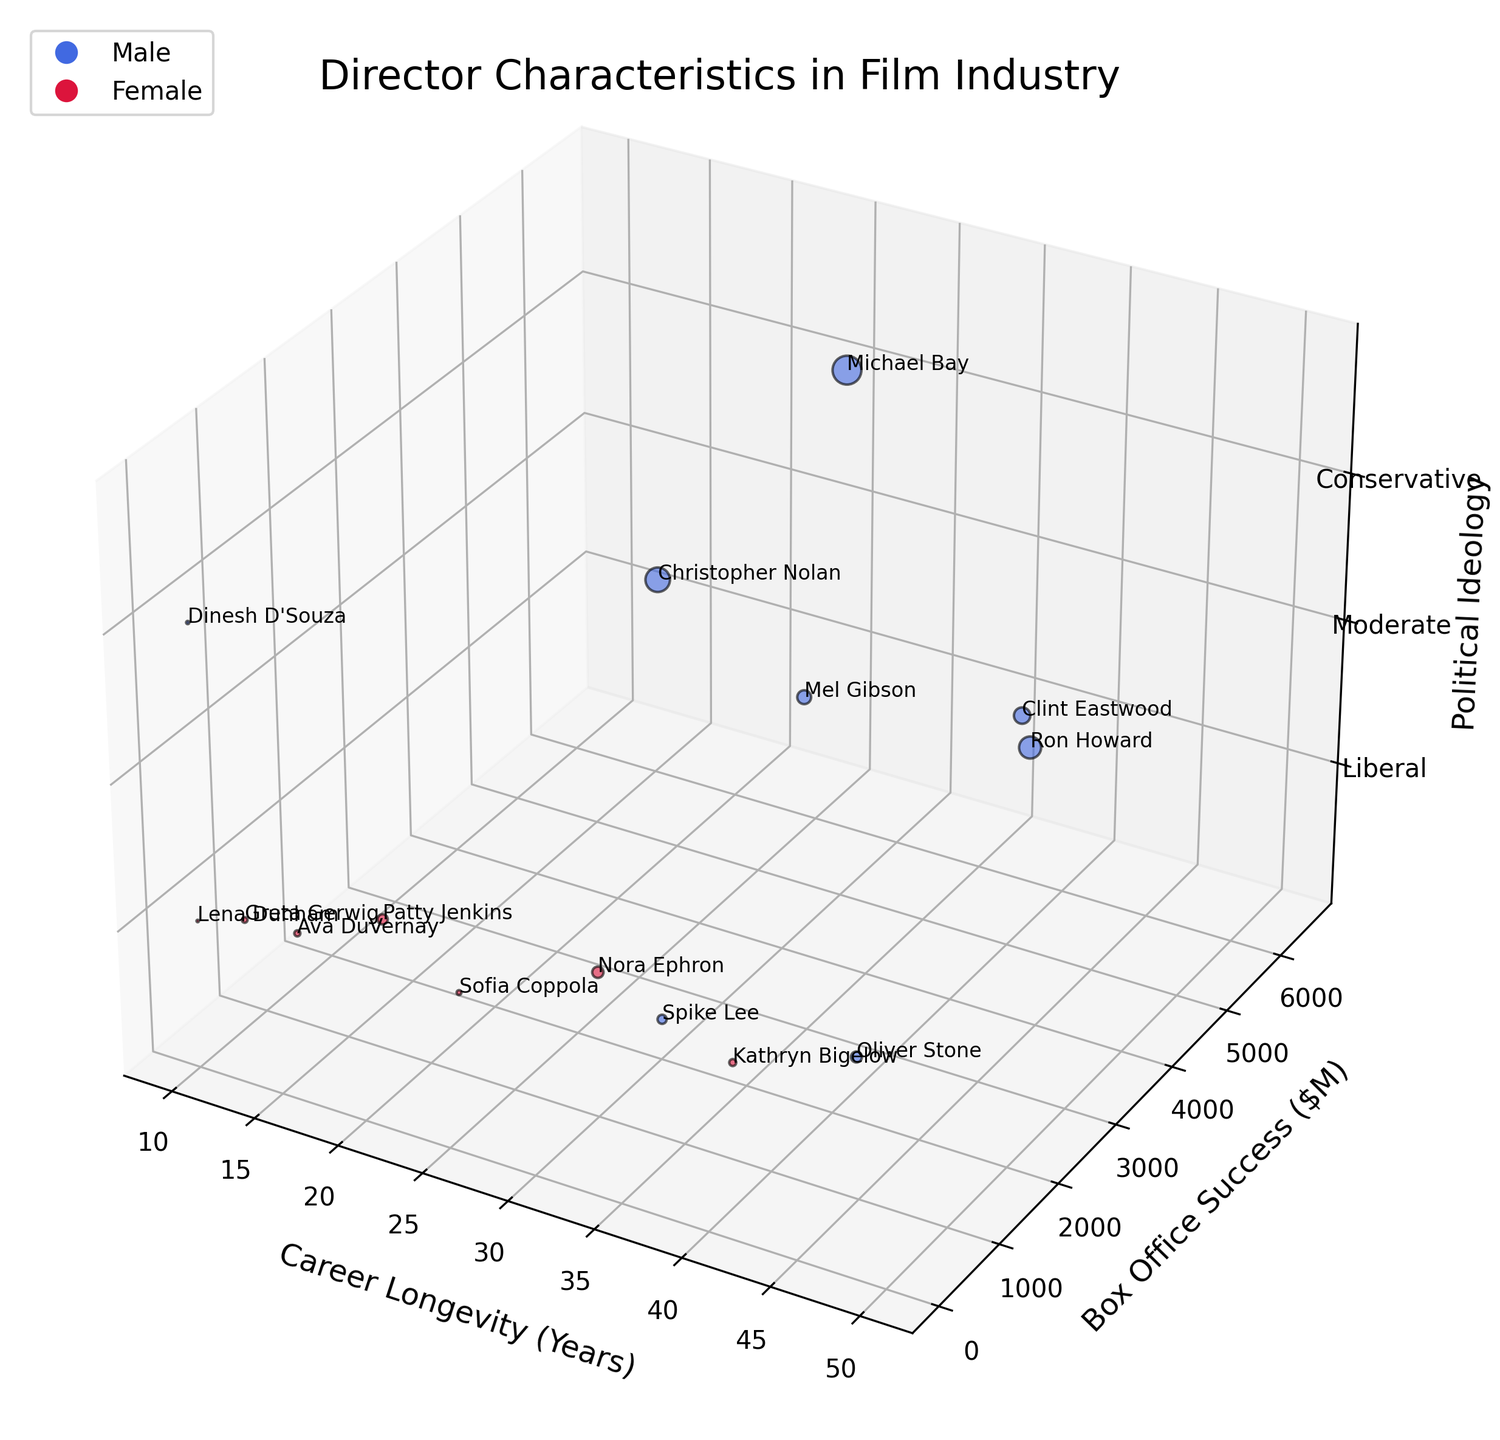How many data points represent female directors in the figure? To find the number of female directors, look at the color representing females (crimson). Then count the bubbles in the figure with this color.
Answer: 7 Which two directors have the longest career longevity among the liberal directors? To identify the two liberal directors with the longest careers, filter by political ideology (z-axis value 0), and compare the career longevity values (x-axis).
Answer: Oliver Stone and Spike Lee Which director has the highest box office success among conservative filmmakers? Focus on the conservative directors (z-axis value 2) and identify the one with the highest box office success (y-axis value).
Answer: Michael Bay What is the average box office success for female directors? Identify the female directors (color: crimson) and sum their box office successes, then divide by the number of female directors: (380 + 290 + 250 + 180 + 820 + 1000 + 45) / 7.
Answer: 423.57 Which director's bubble is the largest, and what does it represent? The size of the bubbles represents box office success. Identify the largest bubble by its size.
Answer: Michael Bay; $6500M Compare the career longevity of the moderate directors. Who has a longer career? Look at the bubbles with a z-axis value of 1 (representing moderates) and compare their x-axis values (career longevity).
Answer: Ron Howard Which liberal director has a shorter career longevity than Clint Eastwood but higher box office success than Dinesh D'Souza? Compare liberal directors' (z-axis value 0) career longevity with Clint Eastwood (50 years), then check their box office success values against Dinesh D'Souza ($80M).
Answer: Nora Ephron Is there a correlation between career longevity and box office success for conservative directors? Analyze the conservative directors' (z-axis value 2) data points to see if higher career longevity is associated with higher box office success.
Answer: No clear correlation 